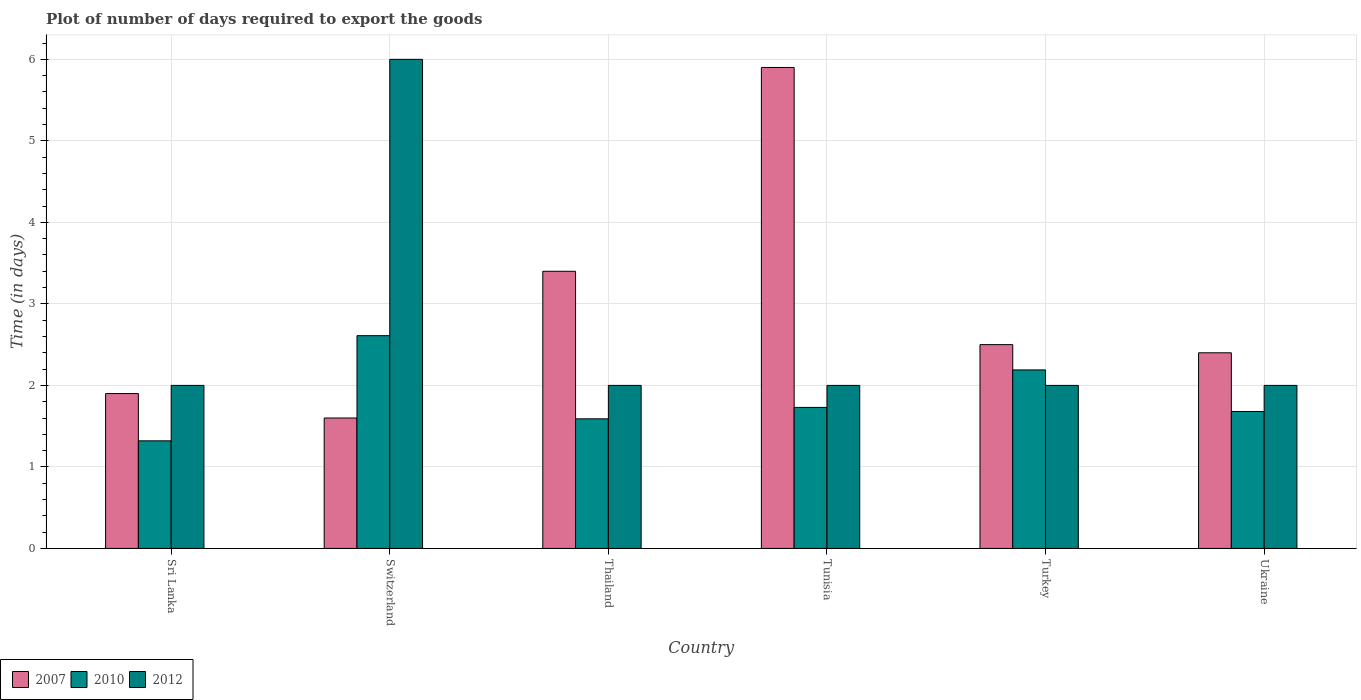How many groups of bars are there?
Make the answer very short. 6. Are the number of bars per tick equal to the number of legend labels?
Your response must be concise. Yes. Are the number of bars on each tick of the X-axis equal?
Ensure brevity in your answer.  Yes. How many bars are there on the 2nd tick from the left?
Provide a short and direct response. 3. What is the label of the 3rd group of bars from the left?
Offer a very short reply. Thailand. In how many cases, is the number of bars for a given country not equal to the number of legend labels?
Offer a terse response. 0. What is the time required to export goods in 2012 in Turkey?
Keep it short and to the point. 2. Across all countries, what is the minimum time required to export goods in 2010?
Ensure brevity in your answer.  1.32. In which country was the time required to export goods in 2010 maximum?
Provide a succinct answer. Switzerland. In which country was the time required to export goods in 2012 minimum?
Your answer should be very brief. Sri Lanka. What is the total time required to export goods in 2010 in the graph?
Provide a short and direct response. 11.12. What is the difference between the time required to export goods in 2007 in Thailand and that in Tunisia?
Provide a short and direct response. -2.5. What is the difference between the time required to export goods in 2010 in Turkey and the time required to export goods in 2007 in Thailand?
Offer a terse response. -1.21. What is the average time required to export goods in 2007 per country?
Provide a short and direct response. 2.95. What is the difference between the time required to export goods of/in 2012 and time required to export goods of/in 2010 in Sri Lanka?
Give a very brief answer. 0.68. In how many countries, is the time required to export goods in 2007 greater than 2.6 days?
Offer a terse response. 2. What is the ratio of the time required to export goods in 2012 in Sri Lanka to that in Switzerland?
Keep it short and to the point. 0.33. Is the time required to export goods in 2007 in Turkey less than that in Ukraine?
Keep it short and to the point. No. Is the difference between the time required to export goods in 2012 in Switzerland and Turkey greater than the difference between the time required to export goods in 2010 in Switzerland and Turkey?
Your response must be concise. Yes. What is the difference between the highest and the second highest time required to export goods in 2012?
Your response must be concise. -4. What is the difference between the highest and the lowest time required to export goods in 2010?
Provide a succinct answer. 1.29. In how many countries, is the time required to export goods in 2012 greater than the average time required to export goods in 2012 taken over all countries?
Offer a very short reply. 1. Is the sum of the time required to export goods in 2012 in Switzerland and Ukraine greater than the maximum time required to export goods in 2010 across all countries?
Your answer should be compact. Yes. What does the 2nd bar from the left in Thailand represents?
Provide a succinct answer. 2010. Is it the case that in every country, the sum of the time required to export goods in 2010 and time required to export goods in 2007 is greater than the time required to export goods in 2012?
Your response must be concise. No. Are all the bars in the graph horizontal?
Provide a succinct answer. No. How many countries are there in the graph?
Provide a short and direct response. 6. Does the graph contain any zero values?
Offer a terse response. No. How are the legend labels stacked?
Make the answer very short. Horizontal. What is the title of the graph?
Provide a succinct answer. Plot of number of days required to export the goods. Does "2012" appear as one of the legend labels in the graph?
Your response must be concise. Yes. What is the label or title of the Y-axis?
Ensure brevity in your answer.  Time (in days). What is the Time (in days) in 2007 in Sri Lanka?
Ensure brevity in your answer.  1.9. What is the Time (in days) in 2010 in Sri Lanka?
Give a very brief answer. 1.32. What is the Time (in days) of 2012 in Sri Lanka?
Keep it short and to the point. 2. What is the Time (in days) of 2010 in Switzerland?
Offer a very short reply. 2.61. What is the Time (in days) of 2007 in Thailand?
Your response must be concise. 3.4. What is the Time (in days) of 2010 in Thailand?
Your answer should be very brief. 1.59. What is the Time (in days) in 2012 in Thailand?
Your answer should be compact. 2. What is the Time (in days) of 2010 in Tunisia?
Give a very brief answer. 1.73. What is the Time (in days) of 2007 in Turkey?
Keep it short and to the point. 2.5. What is the Time (in days) of 2010 in Turkey?
Your response must be concise. 2.19. What is the Time (in days) in 2012 in Turkey?
Your answer should be compact. 2. What is the Time (in days) of 2007 in Ukraine?
Offer a terse response. 2.4. What is the Time (in days) in 2010 in Ukraine?
Offer a very short reply. 1.68. What is the Time (in days) of 2012 in Ukraine?
Make the answer very short. 2. Across all countries, what is the maximum Time (in days) of 2010?
Make the answer very short. 2.61. Across all countries, what is the maximum Time (in days) of 2012?
Your answer should be very brief. 6. Across all countries, what is the minimum Time (in days) of 2007?
Keep it short and to the point. 1.6. Across all countries, what is the minimum Time (in days) of 2010?
Your answer should be very brief. 1.32. Across all countries, what is the minimum Time (in days) of 2012?
Make the answer very short. 2. What is the total Time (in days) in 2007 in the graph?
Offer a very short reply. 17.7. What is the total Time (in days) of 2010 in the graph?
Offer a terse response. 11.12. What is the difference between the Time (in days) of 2010 in Sri Lanka and that in Switzerland?
Offer a very short reply. -1.29. What is the difference between the Time (in days) in 2010 in Sri Lanka and that in Thailand?
Keep it short and to the point. -0.27. What is the difference between the Time (in days) of 2012 in Sri Lanka and that in Thailand?
Your answer should be compact. 0. What is the difference between the Time (in days) of 2010 in Sri Lanka and that in Tunisia?
Give a very brief answer. -0.41. What is the difference between the Time (in days) in 2007 in Sri Lanka and that in Turkey?
Your answer should be compact. -0.6. What is the difference between the Time (in days) of 2010 in Sri Lanka and that in Turkey?
Keep it short and to the point. -0.87. What is the difference between the Time (in days) of 2010 in Sri Lanka and that in Ukraine?
Your answer should be compact. -0.36. What is the difference between the Time (in days) in 2010 in Switzerland and that in Thailand?
Ensure brevity in your answer.  1.02. What is the difference between the Time (in days) in 2012 in Switzerland and that in Thailand?
Your answer should be compact. 4. What is the difference between the Time (in days) of 2007 in Switzerland and that in Tunisia?
Your response must be concise. -4.3. What is the difference between the Time (in days) in 2010 in Switzerland and that in Tunisia?
Make the answer very short. 0.88. What is the difference between the Time (in days) of 2012 in Switzerland and that in Tunisia?
Keep it short and to the point. 4. What is the difference between the Time (in days) of 2010 in Switzerland and that in Turkey?
Your answer should be compact. 0.42. What is the difference between the Time (in days) in 2012 in Switzerland and that in Turkey?
Offer a very short reply. 4. What is the difference between the Time (in days) of 2010 in Switzerland and that in Ukraine?
Offer a very short reply. 0.93. What is the difference between the Time (in days) of 2007 in Thailand and that in Tunisia?
Your response must be concise. -2.5. What is the difference between the Time (in days) in 2010 in Thailand and that in Tunisia?
Ensure brevity in your answer.  -0.14. What is the difference between the Time (in days) of 2012 in Thailand and that in Tunisia?
Provide a short and direct response. 0. What is the difference between the Time (in days) of 2010 in Thailand and that in Turkey?
Ensure brevity in your answer.  -0.6. What is the difference between the Time (in days) of 2012 in Thailand and that in Turkey?
Provide a succinct answer. 0. What is the difference between the Time (in days) of 2010 in Thailand and that in Ukraine?
Keep it short and to the point. -0.09. What is the difference between the Time (in days) of 2007 in Tunisia and that in Turkey?
Your answer should be compact. 3.4. What is the difference between the Time (in days) in 2010 in Tunisia and that in Turkey?
Offer a very short reply. -0.46. What is the difference between the Time (in days) in 2010 in Tunisia and that in Ukraine?
Offer a terse response. 0.05. What is the difference between the Time (in days) of 2010 in Turkey and that in Ukraine?
Offer a very short reply. 0.51. What is the difference between the Time (in days) of 2007 in Sri Lanka and the Time (in days) of 2010 in Switzerland?
Ensure brevity in your answer.  -0.71. What is the difference between the Time (in days) in 2007 in Sri Lanka and the Time (in days) in 2012 in Switzerland?
Ensure brevity in your answer.  -4.1. What is the difference between the Time (in days) in 2010 in Sri Lanka and the Time (in days) in 2012 in Switzerland?
Offer a very short reply. -4.68. What is the difference between the Time (in days) in 2007 in Sri Lanka and the Time (in days) in 2010 in Thailand?
Provide a succinct answer. 0.31. What is the difference between the Time (in days) of 2010 in Sri Lanka and the Time (in days) of 2012 in Thailand?
Your answer should be compact. -0.68. What is the difference between the Time (in days) in 2007 in Sri Lanka and the Time (in days) in 2010 in Tunisia?
Make the answer very short. 0.17. What is the difference between the Time (in days) in 2010 in Sri Lanka and the Time (in days) in 2012 in Tunisia?
Provide a short and direct response. -0.68. What is the difference between the Time (in days) of 2007 in Sri Lanka and the Time (in days) of 2010 in Turkey?
Provide a succinct answer. -0.29. What is the difference between the Time (in days) in 2007 in Sri Lanka and the Time (in days) in 2012 in Turkey?
Your answer should be compact. -0.1. What is the difference between the Time (in days) of 2010 in Sri Lanka and the Time (in days) of 2012 in Turkey?
Give a very brief answer. -0.68. What is the difference between the Time (in days) of 2007 in Sri Lanka and the Time (in days) of 2010 in Ukraine?
Your answer should be very brief. 0.22. What is the difference between the Time (in days) of 2007 in Sri Lanka and the Time (in days) of 2012 in Ukraine?
Ensure brevity in your answer.  -0.1. What is the difference between the Time (in days) in 2010 in Sri Lanka and the Time (in days) in 2012 in Ukraine?
Make the answer very short. -0.68. What is the difference between the Time (in days) of 2007 in Switzerland and the Time (in days) of 2010 in Thailand?
Offer a very short reply. 0.01. What is the difference between the Time (in days) of 2010 in Switzerland and the Time (in days) of 2012 in Thailand?
Your response must be concise. 0.61. What is the difference between the Time (in days) of 2007 in Switzerland and the Time (in days) of 2010 in Tunisia?
Ensure brevity in your answer.  -0.13. What is the difference between the Time (in days) in 2007 in Switzerland and the Time (in days) in 2012 in Tunisia?
Offer a very short reply. -0.4. What is the difference between the Time (in days) of 2010 in Switzerland and the Time (in days) of 2012 in Tunisia?
Offer a very short reply. 0.61. What is the difference between the Time (in days) of 2007 in Switzerland and the Time (in days) of 2010 in Turkey?
Offer a very short reply. -0.59. What is the difference between the Time (in days) of 2010 in Switzerland and the Time (in days) of 2012 in Turkey?
Provide a succinct answer. 0.61. What is the difference between the Time (in days) of 2007 in Switzerland and the Time (in days) of 2010 in Ukraine?
Offer a terse response. -0.08. What is the difference between the Time (in days) in 2007 in Switzerland and the Time (in days) in 2012 in Ukraine?
Make the answer very short. -0.4. What is the difference between the Time (in days) in 2010 in Switzerland and the Time (in days) in 2012 in Ukraine?
Offer a terse response. 0.61. What is the difference between the Time (in days) in 2007 in Thailand and the Time (in days) in 2010 in Tunisia?
Provide a short and direct response. 1.67. What is the difference between the Time (in days) of 2010 in Thailand and the Time (in days) of 2012 in Tunisia?
Ensure brevity in your answer.  -0.41. What is the difference between the Time (in days) in 2007 in Thailand and the Time (in days) in 2010 in Turkey?
Offer a very short reply. 1.21. What is the difference between the Time (in days) of 2010 in Thailand and the Time (in days) of 2012 in Turkey?
Offer a very short reply. -0.41. What is the difference between the Time (in days) of 2007 in Thailand and the Time (in days) of 2010 in Ukraine?
Offer a terse response. 1.72. What is the difference between the Time (in days) of 2007 in Thailand and the Time (in days) of 2012 in Ukraine?
Keep it short and to the point. 1.4. What is the difference between the Time (in days) of 2010 in Thailand and the Time (in days) of 2012 in Ukraine?
Your response must be concise. -0.41. What is the difference between the Time (in days) of 2007 in Tunisia and the Time (in days) of 2010 in Turkey?
Give a very brief answer. 3.71. What is the difference between the Time (in days) in 2007 in Tunisia and the Time (in days) in 2012 in Turkey?
Make the answer very short. 3.9. What is the difference between the Time (in days) in 2010 in Tunisia and the Time (in days) in 2012 in Turkey?
Your answer should be compact. -0.27. What is the difference between the Time (in days) in 2007 in Tunisia and the Time (in days) in 2010 in Ukraine?
Give a very brief answer. 4.22. What is the difference between the Time (in days) in 2007 in Tunisia and the Time (in days) in 2012 in Ukraine?
Provide a short and direct response. 3.9. What is the difference between the Time (in days) of 2010 in Tunisia and the Time (in days) of 2012 in Ukraine?
Your response must be concise. -0.27. What is the difference between the Time (in days) of 2007 in Turkey and the Time (in days) of 2010 in Ukraine?
Make the answer very short. 0.82. What is the difference between the Time (in days) in 2007 in Turkey and the Time (in days) in 2012 in Ukraine?
Make the answer very short. 0.5. What is the difference between the Time (in days) of 2010 in Turkey and the Time (in days) of 2012 in Ukraine?
Keep it short and to the point. 0.19. What is the average Time (in days) in 2007 per country?
Keep it short and to the point. 2.95. What is the average Time (in days) of 2010 per country?
Your answer should be compact. 1.85. What is the average Time (in days) of 2012 per country?
Your answer should be compact. 2.67. What is the difference between the Time (in days) in 2007 and Time (in days) in 2010 in Sri Lanka?
Offer a very short reply. 0.58. What is the difference between the Time (in days) in 2010 and Time (in days) in 2012 in Sri Lanka?
Offer a terse response. -0.68. What is the difference between the Time (in days) of 2007 and Time (in days) of 2010 in Switzerland?
Ensure brevity in your answer.  -1.01. What is the difference between the Time (in days) of 2007 and Time (in days) of 2012 in Switzerland?
Offer a terse response. -4.4. What is the difference between the Time (in days) of 2010 and Time (in days) of 2012 in Switzerland?
Your response must be concise. -3.39. What is the difference between the Time (in days) of 2007 and Time (in days) of 2010 in Thailand?
Offer a very short reply. 1.81. What is the difference between the Time (in days) in 2007 and Time (in days) in 2012 in Thailand?
Offer a terse response. 1.4. What is the difference between the Time (in days) of 2010 and Time (in days) of 2012 in Thailand?
Your answer should be compact. -0.41. What is the difference between the Time (in days) in 2007 and Time (in days) in 2010 in Tunisia?
Offer a terse response. 4.17. What is the difference between the Time (in days) of 2010 and Time (in days) of 2012 in Tunisia?
Provide a succinct answer. -0.27. What is the difference between the Time (in days) of 2007 and Time (in days) of 2010 in Turkey?
Make the answer very short. 0.31. What is the difference between the Time (in days) of 2010 and Time (in days) of 2012 in Turkey?
Make the answer very short. 0.19. What is the difference between the Time (in days) of 2007 and Time (in days) of 2010 in Ukraine?
Your response must be concise. 0.72. What is the difference between the Time (in days) of 2007 and Time (in days) of 2012 in Ukraine?
Your response must be concise. 0.4. What is the difference between the Time (in days) of 2010 and Time (in days) of 2012 in Ukraine?
Make the answer very short. -0.32. What is the ratio of the Time (in days) of 2007 in Sri Lanka to that in Switzerland?
Offer a very short reply. 1.19. What is the ratio of the Time (in days) in 2010 in Sri Lanka to that in Switzerland?
Your answer should be very brief. 0.51. What is the ratio of the Time (in days) in 2007 in Sri Lanka to that in Thailand?
Offer a very short reply. 0.56. What is the ratio of the Time (in days) of 2010 in Sri Lanka to that in Thailand?
Your response must be concise. 0.83. What is the ratio of the Time (in days) of 2007 in Sri Lanka to that in Tunisia?
Keep it short and to the point. 0.32. What is the ratio of the Time (in days) in 2010 in Sri Lanka to that in Tunisia?
Provide a short and direct response. 0.76. What is the ratio of the Time (in days) in 2007 in Sri Lanka to that in Turkey?
Provide a short and direct response. 0.76. What is the ratio of the Time (in days) in 2010 in Sri Lanka to that in Turkey?
Provide a short and direct response. 0.6. What is the ratio of the Time (in days) of 2012 in Sri Lanka to that in Turkey?
Your answer should be very brief. 1. What is the ratio of the Time (in days) of 2007 in Sri Lanka to that in Ukraine?
Offer a terse response. 0.79. What is the ratio of the Time (in days) in 2010 in Sri Lanka to that in Ukraine?
Give a very brief answer. 0.79. What is the ratio of the Time (in days) of 2012 in Sri Lanka to that in Ukraine?
Give a very brief answer. 1. What is the ratio of the Time (in days) of 2007 in Switzerland to that in Thailand?
Make the answer very short. 0.47. What is the ratio of the Time (in days) of 2010 in Switzerland to that in Thailand?
Ensure brevity in your answer.  1.64. What is the ratio of the Time (in days) of 2007 in Switzerland to that in Tunisia?
Ensure brevity in your answer.  0.27. What is the ratio of the Time (in days) in 2010 in Switzerland to that in Tunisia?
Offer a very short reply. 1.51. What is the ratio of the Time (in days) of 2012 in Switzerland to that in Tunisia?
Provide a succinct answer. 3. What is the ratio of the Time (in days) in 2007 in Switzerland to that in Turkey?
Your answer should be compact. 0.64. What is the ratio of the Time (in days) in 2010 in Switzerland to that in Turkey?
Provide a short and direct response. 1.19. What is the ratio of the Time (in days) of 2010 in Switzerland to that in Ukraine?
Keep it short and to the point. 1.55. What is the ratio of the Time (in days) in 2012 in Switzerland to that in Ukraine?
Your response must be concise. 3. What is the ratio of the Time (in days) of 2007 in Thailand to that in Tunisia?
Ensure brevity in your answer.  0.58. What is the ratio of the Time (in days) in 2010 in Thailand to that in Tunisia?
Make the answer very short. 0.92. What is the ratio of the Time (in days) of 2007 in Thailand to that in Turkey?
Your response must be concise. 1.36. What is the ratio of the Time (in days) of 2010 in Thailand to that in Turkey?
Make the answer very short. 0.73. What is the ratio of the Time (in days) of 2012 in Thailand to that in Turkey?
Ensure brevity in your answer.  1. What is the ratio of the Time (in days) in 2007 in Thailand to that in Ukraine?
Give a very brief answer. 1.42. What is the ratio of the Time (in days) in 2010 in Thailand to that in Ukraine?
Provide a short and direct response. 0.95. What is the ratio of the Time (in days) in 2012 in Thailand to that in Ukraine?
Provide a short and direct response. 1. What is the ratio of the Time (in days) in 2007 in Tunisia to that in Turkey?
Give a very brief answer. 2.36. What is the ratio of the Time (in days) of 2010 in Tunisia to that in Turkey?
Your answer should be very brief. 0.79. What is the ratio of the Time (in days) of 2012 in Tunisia to that in Turkey?
Make the answer very short. 1. What is the ratio of the Time (in days) of 2007 in Tunisia to that in Ukraine?
Offer a terse response. 2.46. What is the ratio of the Time (in days) in 2010 in Tunisia to that in Ukraine?
Provide a short and direct response. 1.03. What is the ratio of the Time (in days) of 2012 in Tunisia to that in Ukraine?
Your answer should be very brief. 1. What is the ratio of the Time (in days) of 2007 in Turkey to that in Ukraine?
Your response must be concise. 1.04. What is the ratio of the Time (in days) in 2010 in Turkey to that in Ukraine?
Give a very brief answer. 1.3. What is the difference between the highest and the second highest Time (in days) in 2010?
Offer a terse response. 0.42. What is the difference between the highest and the lowest Time (in days) of 2007?
Your response must be concise. 4.3. What is the difference between the highest and the lowest Time (in days) in 2010?
Your response must be concise. 1.29. What is the difference between the highest and the lowest Time (in days) of 2012?
Make the answer very short. 4. 